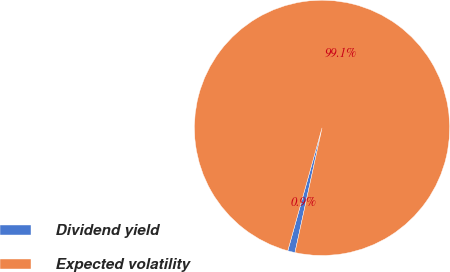Convert chart. <chart><loc_0><loc_0><loc_500><loc_500><pie_chart><fcel>Dividend yield<fcel>Expected volatility<nl><fcel>0.92%<fcel>99.08%<nl></chart> 